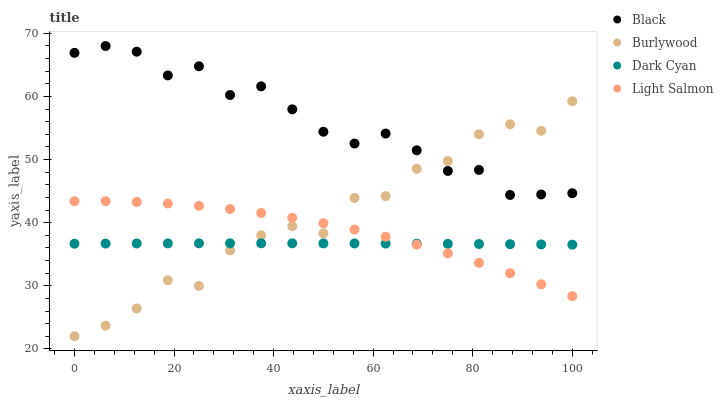Does Dark Cyan have the minimum area under the curve?
Answer yes or no. Yes. Does Black have the maximum area under the curve?
Answer yes or no. Yes. Does Light Salmon have the minimum area under the curve?
Answer yes or no. No. Does Light Salmon have the maximum area under the curve?
Answer yes or no. No. Is Dark Cyan the smoothest?
Answer yes or no. Yes. Is Burlywood the roughest?
Answer yes or no. Yes. Is Light Salmon the smoothest?
Answer yes or no. No. Is Light Salmon the roughest?
Answer yes or no. No. Does Burlywood have the lowest value?
Answer yes or no. Yes. Does Dark Cyan have the lowest value?
Answer yes or no. No. Does Black have the highest value?
Answer yes or no. Yes. Does Light Salmon have the highest value?
Answer yes or no. No. Is Light Salmon less than Black?
Answer yes or no. Yes. Is Black greater than Dark Cyan?
Answer yes or no. Yes. Does Burlywood intersect Light Salmon?
Answer yes or no. Yes. Is Burlywood less than Light Salmon?
Answer yes or no. No. Is Burlywood greater than Light Salmon?
Answer yes or no. No. Does Light Salmon intersect Black?
Answer yes or no. No. 